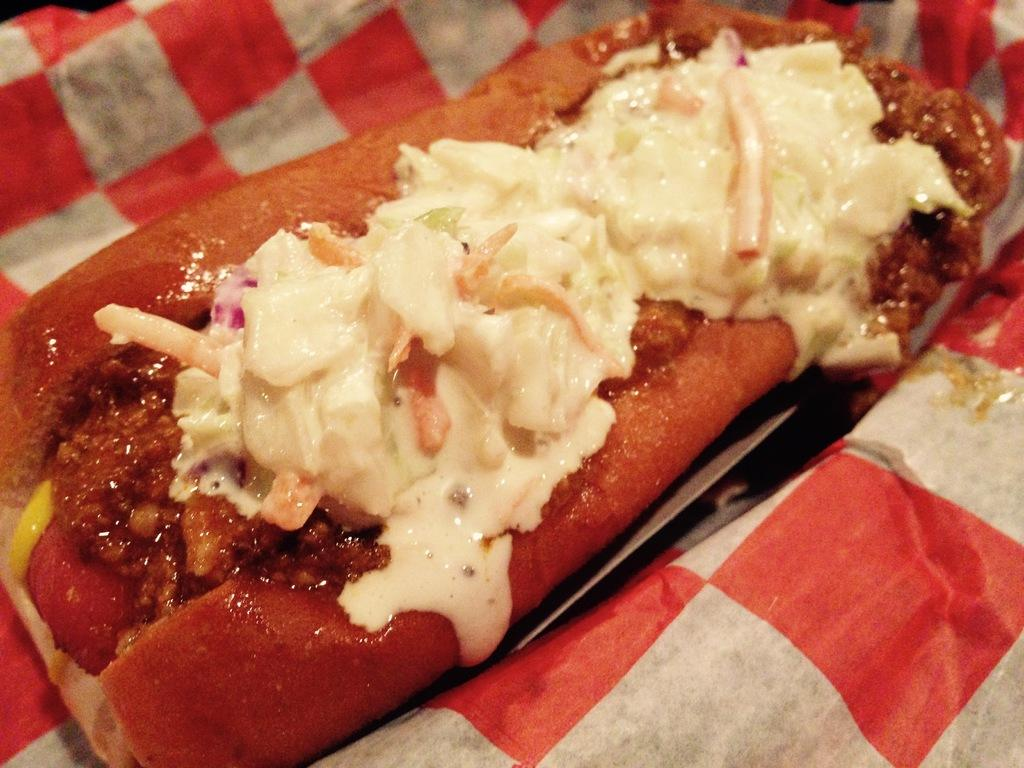What is the main object on the plate in the image? There is a food item present on a plate in the image. Where is the plate located? The plate is on a place, such as a table or countertop. How much money is being exchanged for the food item in the image? There is no indication of money or any transaction in the image; it simply shows a food item on a plate. 